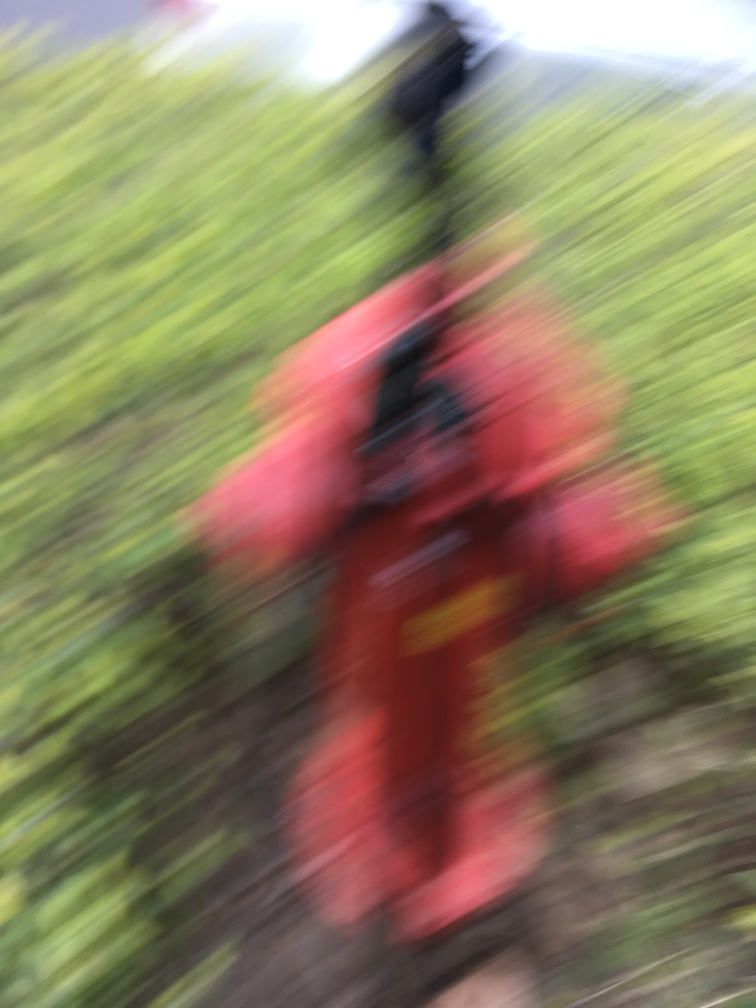Despite the blurriness, can we determine anything about the subject? While the blurriness does obscure fine details, we can infer some basic aspects from the photo. The image seems to display a bright red object, which might be outdoor equipment or clothing, against a backdrop of greenery, which could indicate an outdoor setting. The presence of vibrant colors suggests the subject might be something intended to draw attention or serve a specific purpose in its environment. 